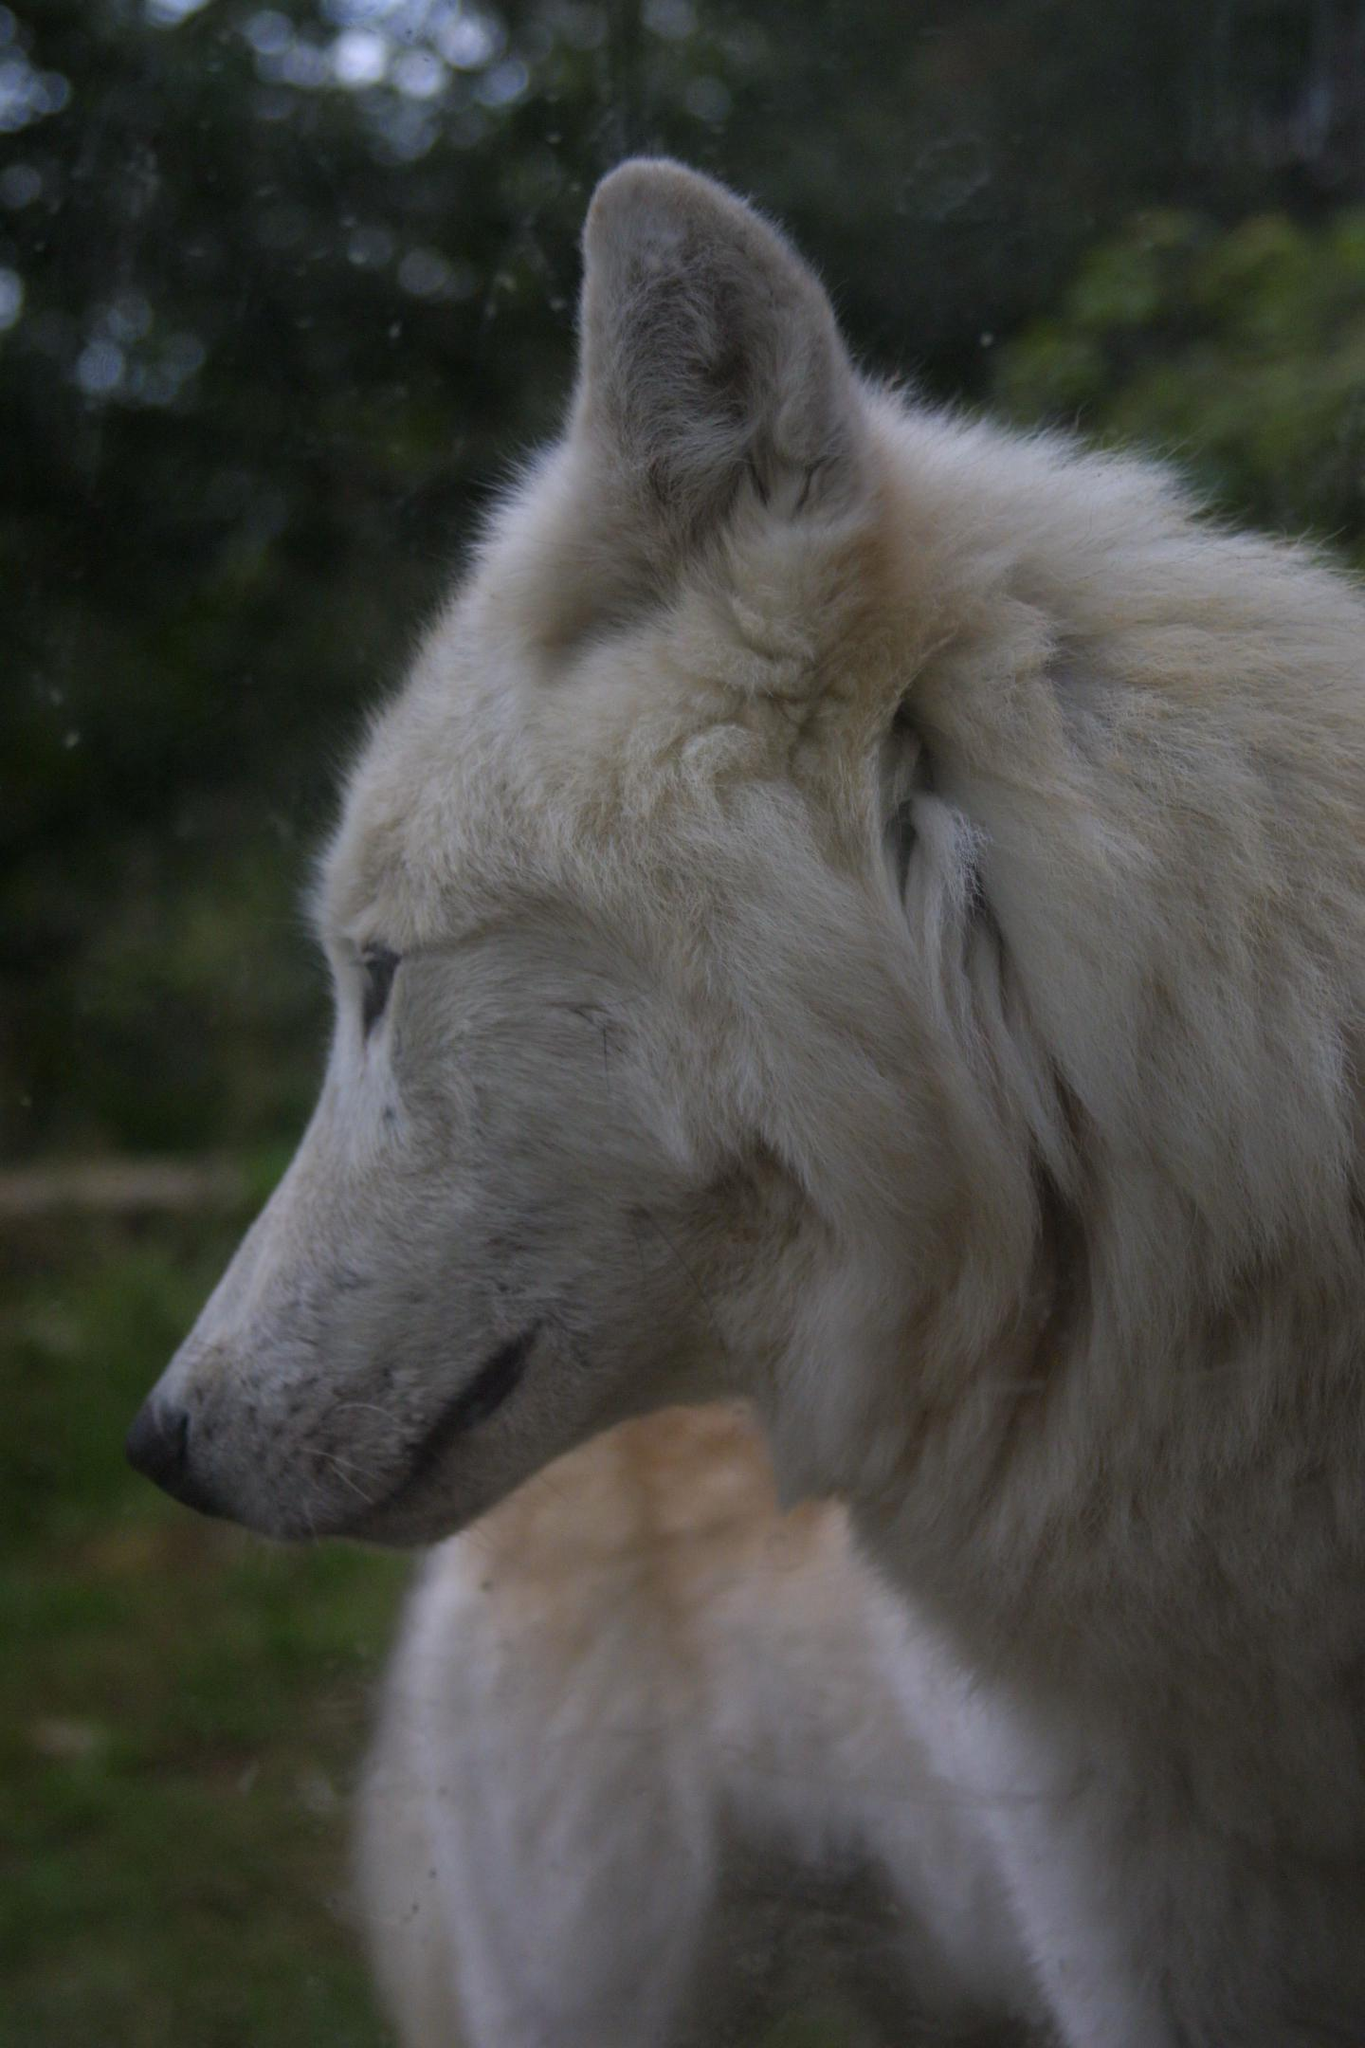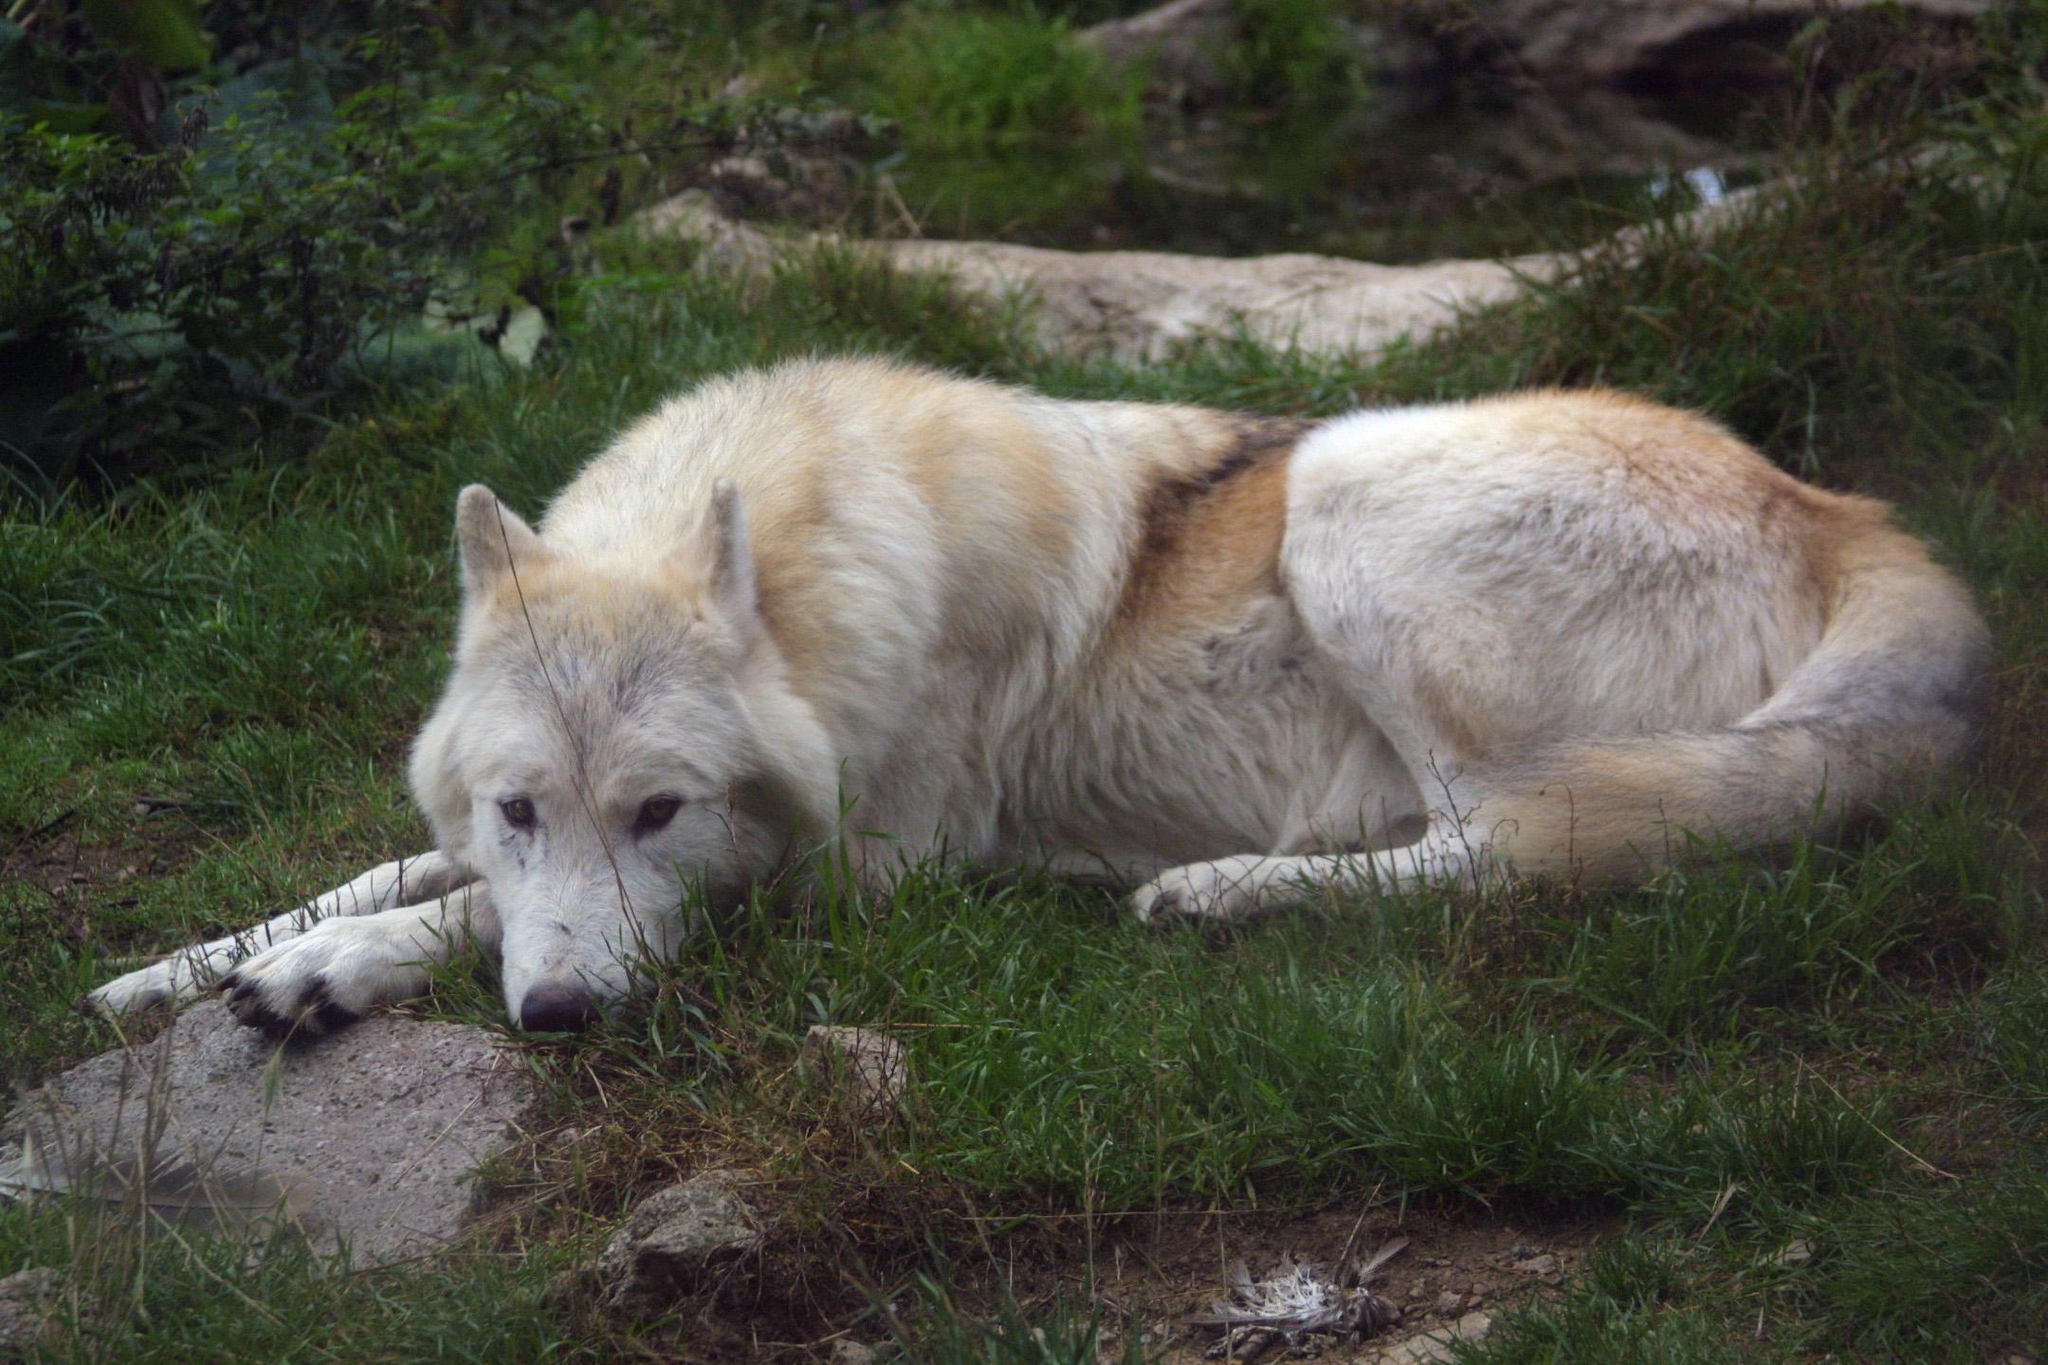The first image is the image on the left, the second image is the image on the right. Examine the images to the left and right. Is the description "One of the wolves' teeth are visible." accurate? Answer yes or no. No. The first image is the image on the left, the second image is the image on the right. Analyze the images presented: Is the assertion "One of the dogs is black with a white muzzle." valid? Answer yes or no. No. 